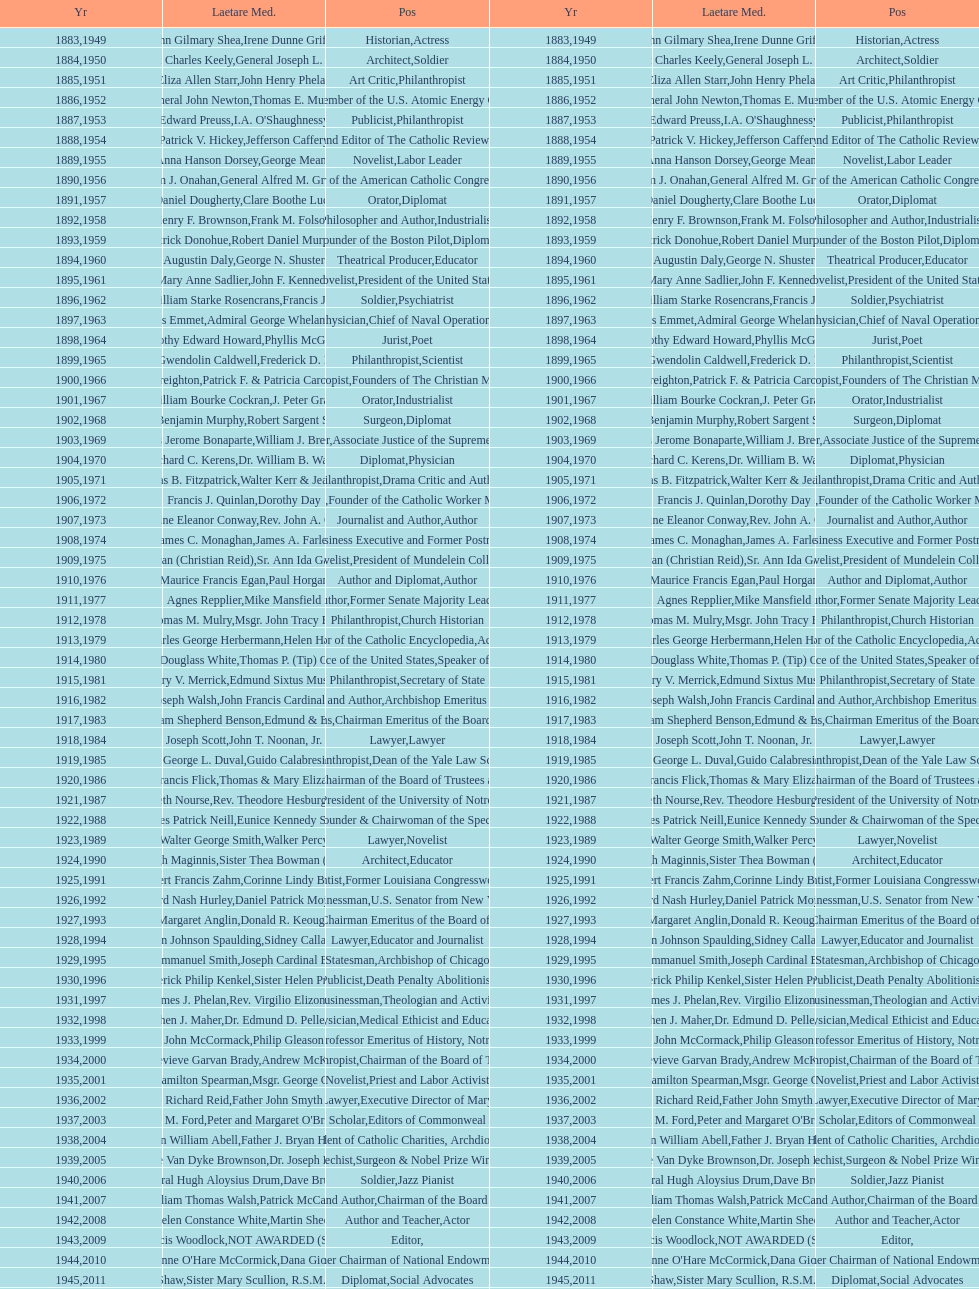How many are or were journalists? 5. Can you give me this table as a dict? {'header': ['Yr', 'Laetare Med.', 'Pos', 'Yr', 'Laetare Med.', 'Pos'], 'rows': [['1883', 'John Gilmary Shea', 'Historian', '1949', 'Irene Dunne Griffin', 'Actress'], ['1884', 'Patrick Charles Keely', 'Architect', '1950', 'General Joseph L. Collins', 'Soldier'], ['1885', 'Eliza Allen Starr', 'Art Critic', '1951', 'John Henry Phelan', 'Philanthropist'], ['1886', 'General John Newton', 'Engineer', '1952', 'Thomas E. Murray', 'Member of the U.S. Atomic Energy Commission'], ['1887', 'Edward Preuss', 'Publicist', '1953', "I.A. O'Shaughnessy", 'Philanthropist'], ['1888', 'Patrick V. Hickey', 'Founder and Editor of The Catholic Review', '1954', 'Jefferson Caffery', 'Diplomat'], ['1889', 'Anna Hanson Dorsey', 'Novelist', '1955', 'George Meany', 'Labor Leader'], ['1890', 'William J. Onahan', 'Organizer of the American Catholic Congress', '1956', 'General Alfred M. Gruenther', 'Soldier'], ['1891', 'Daniel Dougherty', 'Orator', '1957', 'Clare Boothe Luce', 'Diplomat'], ['1892', 'Henry F. Brownson', 'Philosopher and Author', '1958', 'Frank M. Folsom', 'Industrialist'], ['1893', 'Patrick Donohue', 'Founder of the Boston Pilot', '1959', 'Robert Daniel Murphy', 'Diplomat'], ['1894', 'Augustin Daly', 'Theatrical Producer', '1960', 'George N. Shuster', 'Educator'], ['1895', 'Mary Anne Sadlier', 'Novelist', '1961', 'John F. Kennedy', 'President of the United States'], ['1896', 'General William Starke Rosencrans', 'Soldier', '1962', 'Francis J. Braceland', 'Psychiatrist'], ['1897', 'Thomas Addis Emmet', 'Physician', '1963', 'Admiral George Whelan Anderson, Jr.', 'Chief of Naval Operations'], ['1898', 'Timothy Edward Howard', 'Jurist', '1964', 'Phyllis McGinley', 'Poet'], ['1899', 'Mary Gwendolin Caldwell', 'Philanthropist', '1965', 'Frederick D. Rossini', 'Scientist'], ['1900', 'John A. Creighton', 'Philanthropist', '1966', 'Patrick F. & Patricia Caron Crowley', 'Founders of The Christian Movement'], ['1901', 'William Bourke Cockran', 'Orator', '1967', 'J. Peter Grace', 'Industrialist'], ['1902', 'John Benjamin Murphy', 'Surgeon', '1968', 'Robert Sargent Shriver', 'Diplomat'], ['1903', 'Charles Jerome Bonaparte', 'Lawyer', '1969', 'William J. Brennan Jr.', 'Associate Justice of the Supreme Court'], ['1904', 'Richard C. Kerens', 'Diplomat', '1970', 'Dr. William B. Walsh', 'Physician'], ['1905', 'Thomas B. Fitzpatrick', 'Philanthropist', '1971', 'Walter Kerr & Jean Kerr', 'Drama Critic and Author'], ['1906', 'Francis J. Quinlan', 'Physician', '1972', 'Dorothy Day', 'Founder of the Catholic Worker Movement'], ['1907', 'Katherine Eleanor Conway', 'Journalist and Author', '1973', "Rev. John A. O'Brien", 'Author'], ['1908', 'James C. Monaghan', 'Economist', '1974', 'James A. Farley', 'Business Executive and Former Postmaster General'], ['1909', 'Frances Tieran (Christian Reid)', 'Novelist', '1975', 'Sr. Ann Ida Gannon, BMV', 'President of Mundelein College'], ['1910', 'Maurice Francis Egan', 'Author and Diplomat', '1976', 'Paul Horgan', 'Author'], ['1911', 'Agnes Repplier', 'Author', '1977', 'Mike Mansfield', 'Former Senate Majority Leader'], ['1912', 'Thomas M. Mulry', 'Philanthropist', '1978', 'Msgr. John Tracy Ellis', 'Church Historian'], ['1913', 'Charles George Herbermann', 'Editor of the Catholic Encyclopedia', '1979', 'Helen Hayes', 'Actress'], ['1914', 'Edward Douglass White', 'Chief Justice of the United States', '1980', "Thomas P. (Tip) O'Neill Jr.", 'Speaker of the House'], ['1915', 'Mary V. Merrick', 'Philanthropist', '1981', 'Edmund Sixtus Muskie', 'Secretary of State'], ['1916', 'James Joseph Walsh', 'Physician and Author', '1982', 'John Francis Cardinal Dearden', 'Archbishop Emeritus of Detroit'], ['1917', 'Admiral William Shepherd Benson', 'Chief of Naval Operations', '1983', 'Edmund & Evelyn Stephan', 'Chairman Emeritus of the Board of Trustees and his wife'], ['1918', 'Joseph Scott', 'Lawyer', '1984', 'John T. Noonan, Jr.', 'Lawyer'], ['1919', 'George L. Duval', 'Philanthropist', '1985', 'Guido Calabresi', 'Dean of the Yale Law School'], ['1920', 'Lawrence Francis Flick', 'Physician', '1986', 'Thomas & Mary Elizabeth Carney', 'Chairman of the Board of Trustees and his wife'], ['1921', 'Elizabeth Nourse', 'Artist', '1987', 'Rev. Theodore Hesburgh, CSC', 'President of the University of Notre Dame'], ['1922', 'Charles Patrick Neill', 'Economist', '1988', 'Eunice Kennedy Shriver', 'Founder & Chairwoman of the Special Olympics'], ['1923', 'Walter George Smith', 'Lawyer', '1989', 'Walker Percy', 'Novelist'], ['1924', 'Charles Donagh Maginnis', 'Architect', '1990', 'Sister Thea Bowman (posthumously)', 'Educator'], ['1925', 'Albert Francis Zahm', 'Scientist', '1991', 'Corinne Lindy Boggs', 'Former Louisiana Congresswoman'], ['1926', 'Edward Nash Hurley', 'Businessman', '1992', 'Daniel Patrick Moynihan', 'U.S. Senator from New York'], ['1927', 'Margaret Anglin', 'Actress', '1993', 'Donald R. Keough', 'Chairman Emeritus of the Board of Trustees'], ['1928', 'John Johnson Spaulding', 'Lawyer', '1994', 'Sidney Callahan', 'Educator and Journalist'], ['1929', 'Alfred Emmanuel Smith', 'Statesman', '1995', 'Joseph Cardinal Bernardin', 'Archbishop of Chicago'], ['1930', 'Frederick Philip Kenkel', 'Publicist', '1996', 'Sister Helen Prejean', 'Death Penalty Abolitionist'], ['1931', 'James J. Phelan', 'Businessman', '1997', 'Rev. Virgilio Elizondo', 'Theologian and Activist'], ['1932', 'Stephen J. Maher', 'Physician', '1998', 'Dr. Edmund D. Pellegrino', 'Medical Ethicist and Educator'], ['1933', 'John McCormack', 'Artist', '1999', 'Philip Gleason', 'Professor Emeritus of History, Notre Dame'], ['1934', 'Genevieve Garvan Brady', 'Philanthropist', '2000', 'Andrew McKenna', 'Chairman of the Board of Trustees'], ['1935', 'Francis Hamilton Spearman', 'Novelist', '2001', 'Msgr. George G. Higgins', 'Priest and Labor Activist'], ['1936', 'Richard Reid', 'Journalist and Lawyer', '2002', 'Father John Smyth', 'Executive Director of Maryville Academy'], ['1937', 'Jeremiah D. M. Ford', 'Scholar', '2003', "Peter and Margaret O'Brien Steinfels", 'Editors of Commonweal'], ['1938', 'Irvin William Abell', 'Surgeon', '2004', 'Father J. Bryan Hehir', 'President of Catholic Charities, Archdiocese of Boston'], ['1939', 'Josephine Van Dyke Brownson', 'Catechist', '2005', 'Dr. Joseph E. Murray', 'Surgeon & Nobel Prize Winner'], ['1940', 'General Hugh Aloysius Drum', 'Soldier', '2006', 'Dave Brubeck', 'Jazz Pianist'], ['1941', 'William Thomas Walsh', 'Journalist and Author', '2007', 'Patrick McCartan', 'Chairman of the Board of Trustees'], ['1942', 'Helen Constance White', 'Author and Teacher', '2008', 'Martin Sheen', 'Actor'], ['1943', 'Thomas Francis Woodlock', 'Editor', '2009', 'NOT AWARDED (SEE BELOW)', ''], ['1944', "Anne O'Hare McCormick", 'Journalist', '2010', 'Dana Gioia', 'Former Chairman of National Endowment for the Arts'], ['1945', 'Gardiner Howland Shaw', 'Diplomat', '2011', 'Sister Mary Scullion, R.S.M., & Joan McConnon', 'Social Advocates'], ['1946', 'Carlton J. H. Hayes', 'Historian and Diplomat', '2012', 'Ken Hackett', 'Former President of Catholic Relief Services'], ['1947', 'William G. Bruce', 'Publisher and Civic Leader', '2013', 'Sister Susanne Gallagher, S.P.\\nSister Mary Therese Harrington, S.H.\\nRev. James H. McCarthy', 'Founders of S.P.R.E.D. (Special Religious Education Development Network)'], ['1948', 'Frank C. Walker', 'Postmaster General and Civic Leader', '2014', 'Kenneth R. Miller', 'Professor of Biology at Brown University']]} 